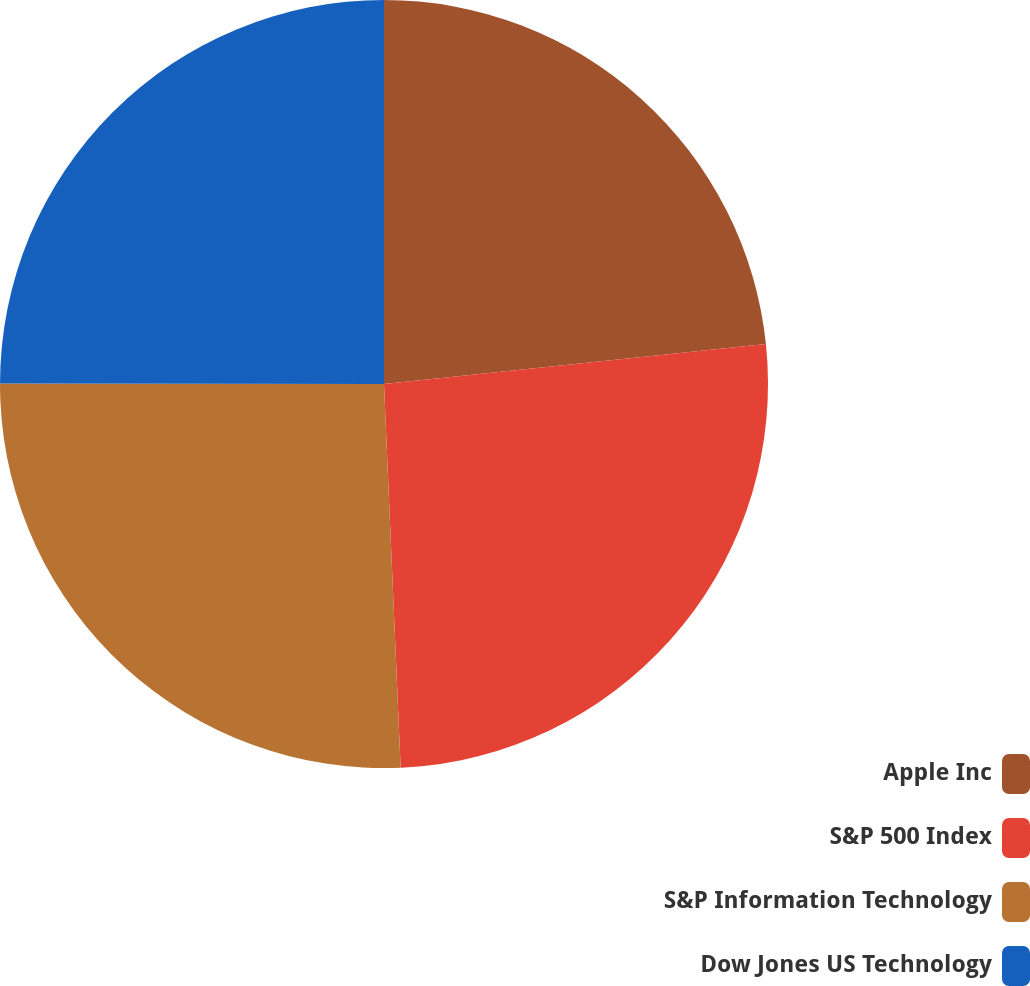<chart> <loc_0><loc_0><loc_500><loc_500><pie_chart><fcel>Apple Inc<fcel>S&P 500 Index<fcel>S&P Information Technology<fcel>Dow Jones US Technology<nl><fcel>23.34%<fcel>25.97%<fcel>25.71%<fcel>24.98%<nl></chart> 